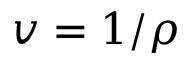Convert formula to latex. <formula><loc_0><loc_0><loc_500><loc_500>v = 1 / \rho</formula> 